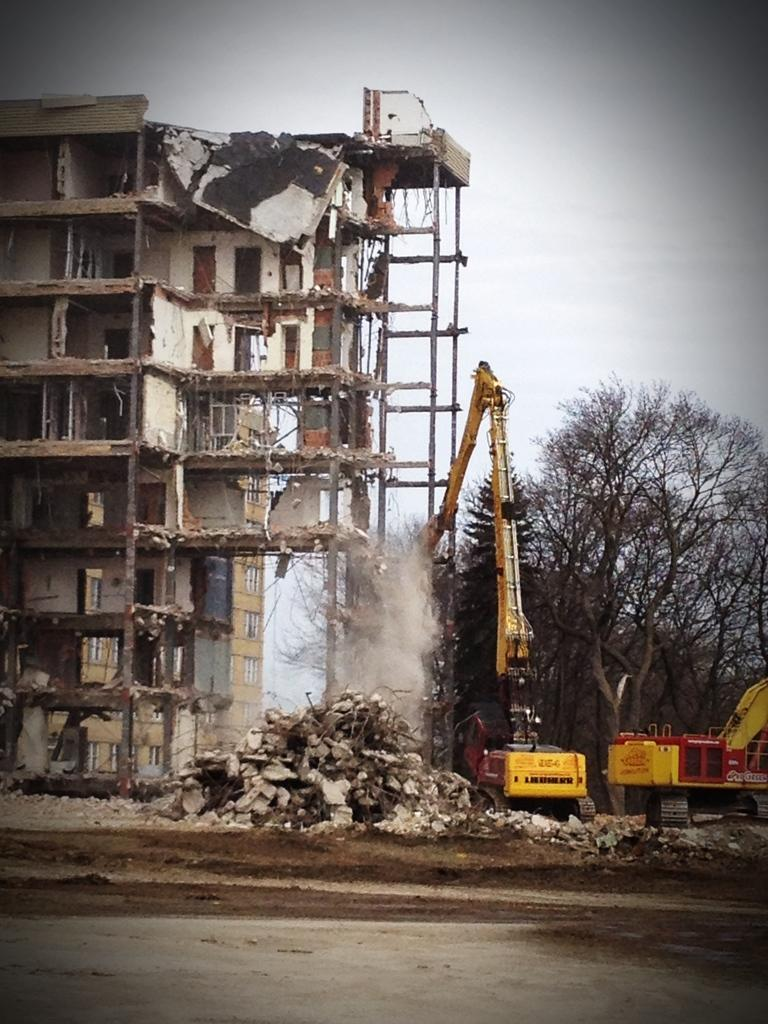What type of structures can be seen in the image? There are buildings in the image. What feature is visible on the buildings? There are windows visible in the image. What type of machinery is present in the image? Cranes are present in the image. What type of natural elements can be seen in the image? Trees and rocks are visible in the image. What is the color of the sky in the image? The sky appears to be white in color. What type of breakfast is being served in the image? There is no breakfast present in the image; it features buildings, windows, cranes, trees, rocks, and a white sky. What is the price of the cars in the image? There are no cars present in the image, so it is not possible to determine their price. 